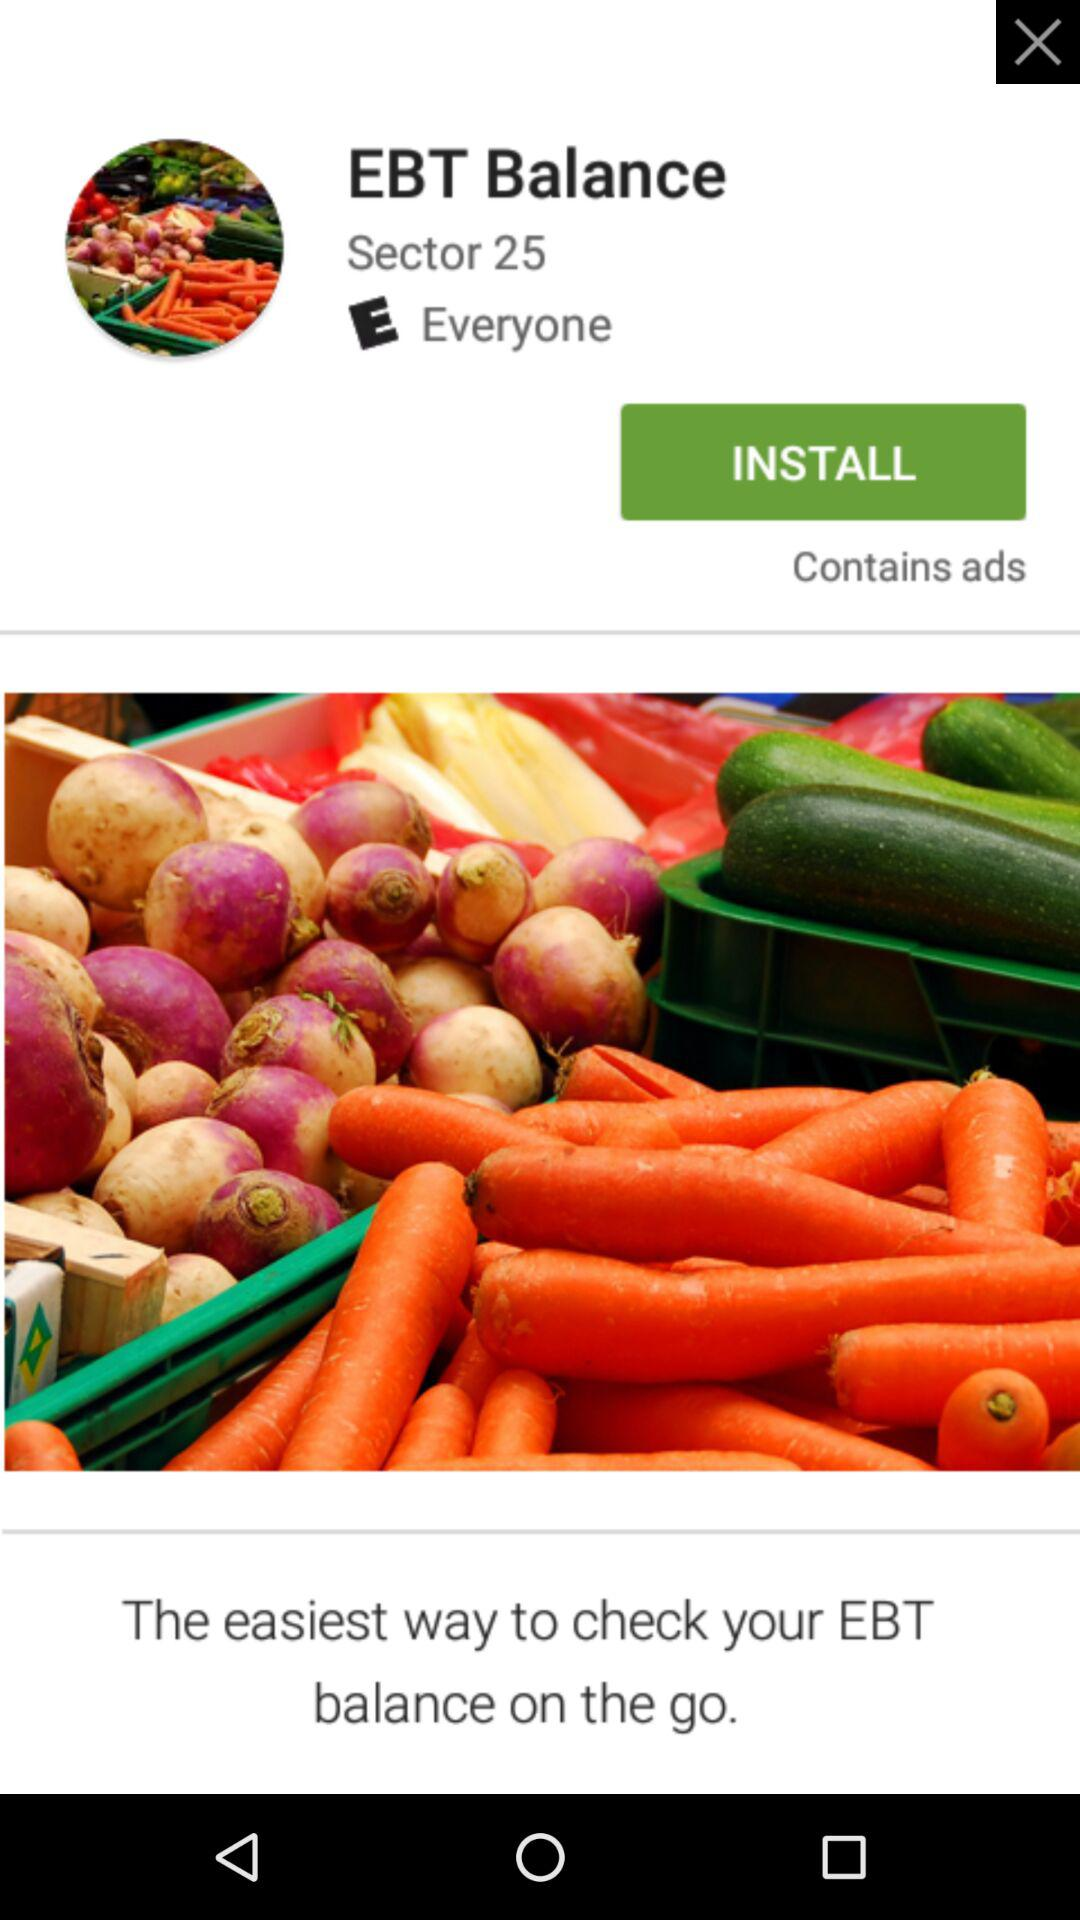How much does "EBT Balance" cost?
When the provided information is insufficient, respond with <no answer>. <no answer> 